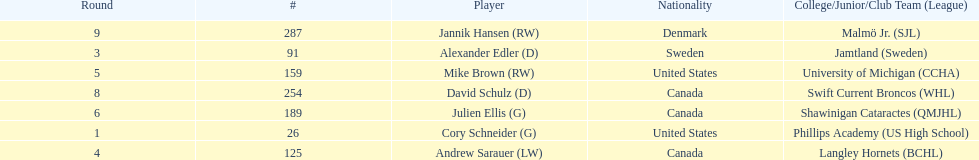Which player was the first player to be drafted? Cory Schneider (G). 